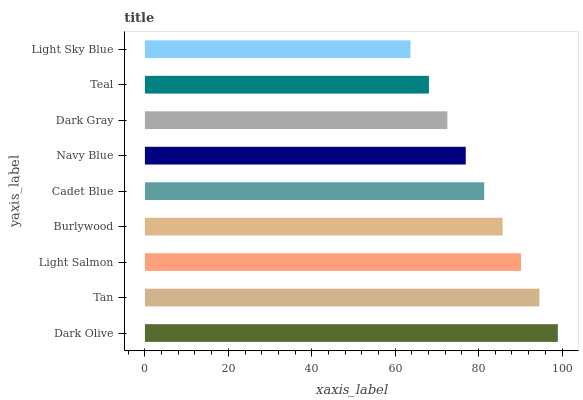Is Light Sky Blue the minimum?
Answer yes or no. Yes. Is Dark Olive the maximum?
Answer yes or no. Yes. Is Tan the minimum?
Answer yes or no. No. Is Tan the maximum?
Answer yes or no. No. Is Dark Olive greater than Tan?
Answer yes or no. Yes. Is Tan less than Dark Olive?
Answer yes or no. Yes. Is Tan greater than Dark Olive?
Answer yes or no. No. Is Dark Olive less than Tan?
Answer yes or no. No. Is Cadet Blue the high median?
Answer yes or no. Yes. Is Cadet Blue the low median?
Answer yes or no. Yes. Is Navy Blue the high median?
Answer yes or no. No. Is Light Sky Blue the low median?
Answer yes or no. No. 